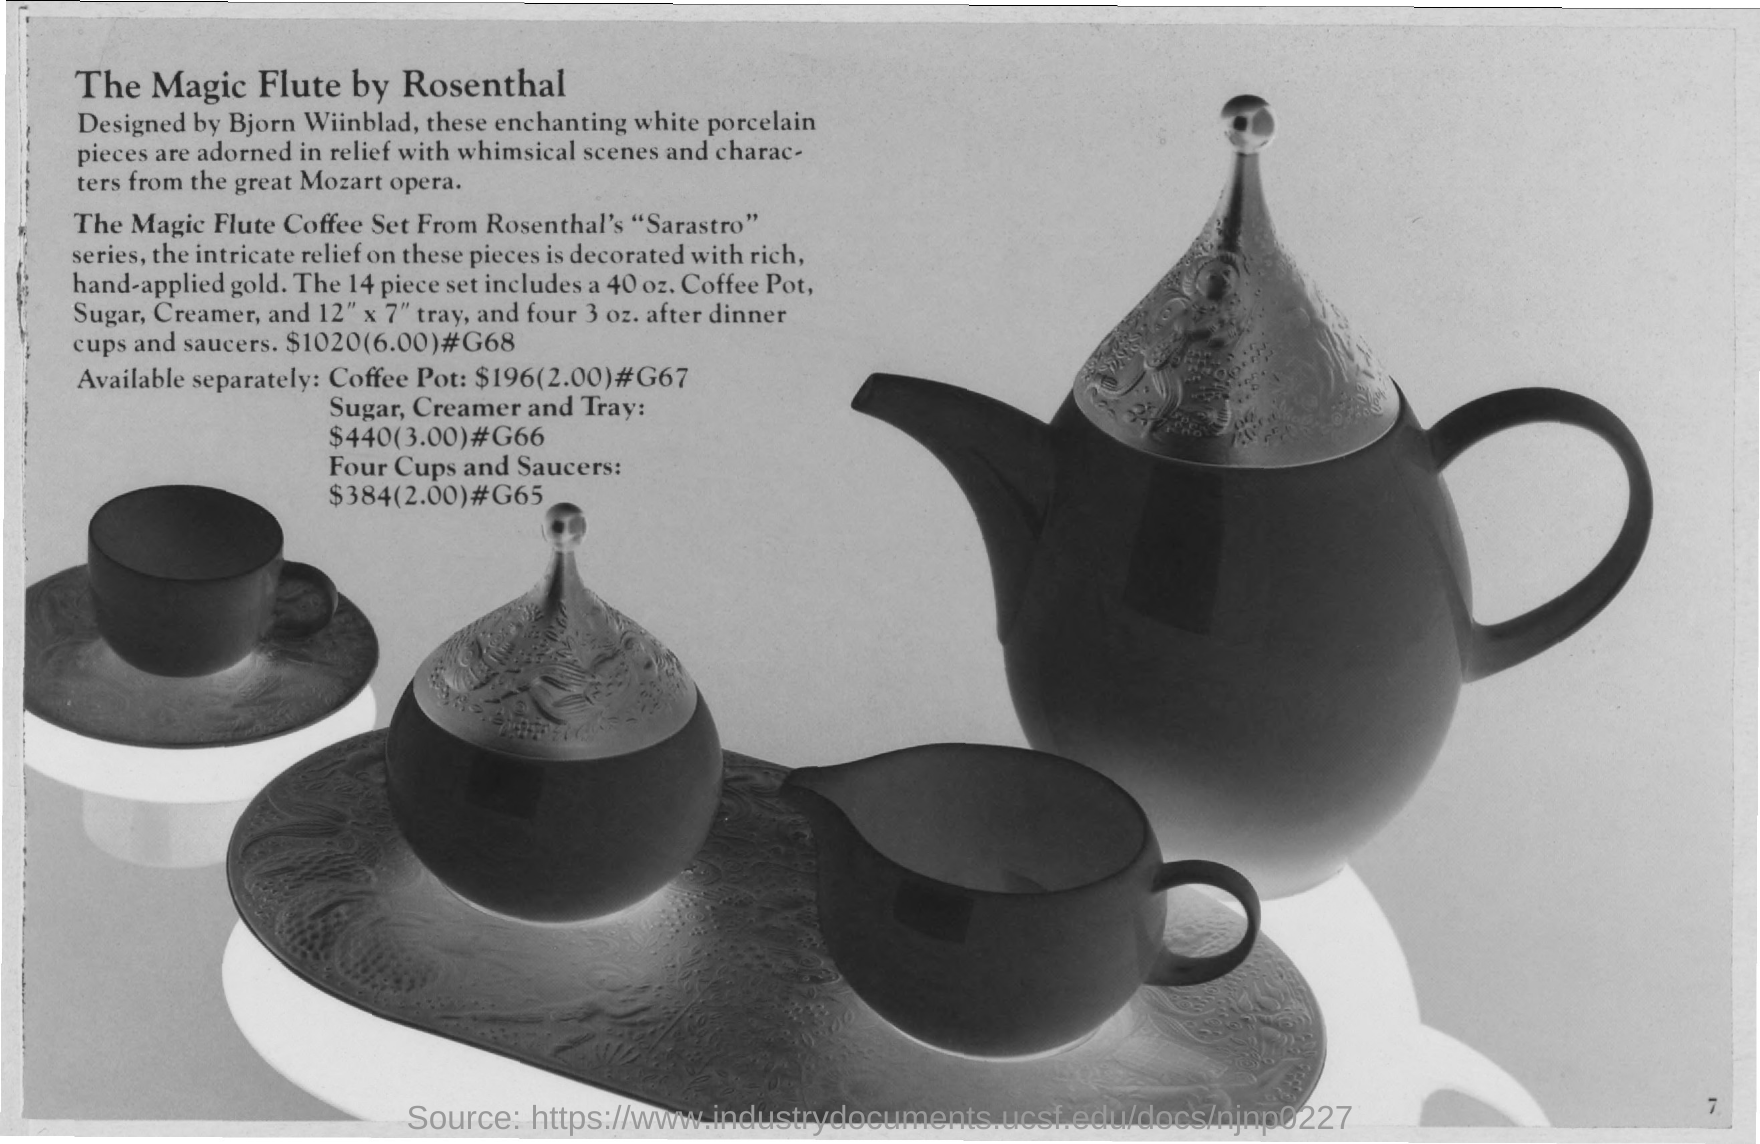Point out several critical features in this image. The Magic Flute Coffee Set is from the Sarastro series. 